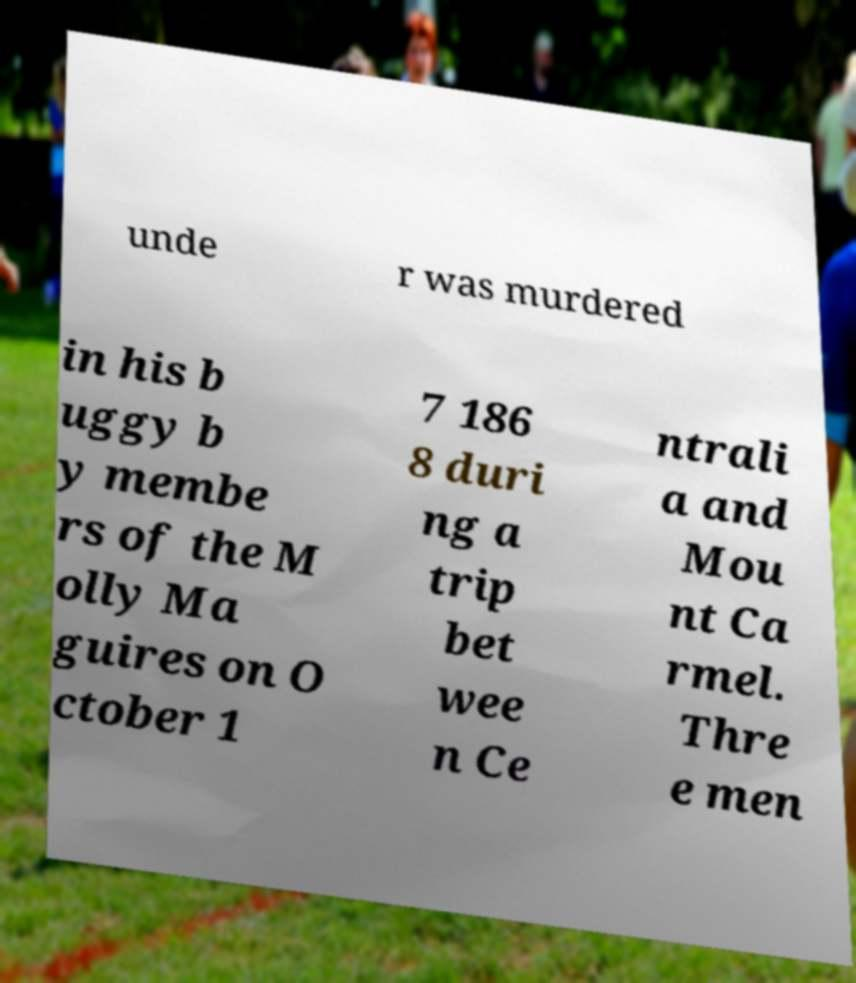Can you accurately transcribe the text from the provided image for me? unde r was murdered in his b uggy b y membe rs of the M olly Ma guires on O ctober 1 7 186 8 duri ng a trip bet wee n Ce ntrali a and Mou nt Ca rmel. Thre e men 